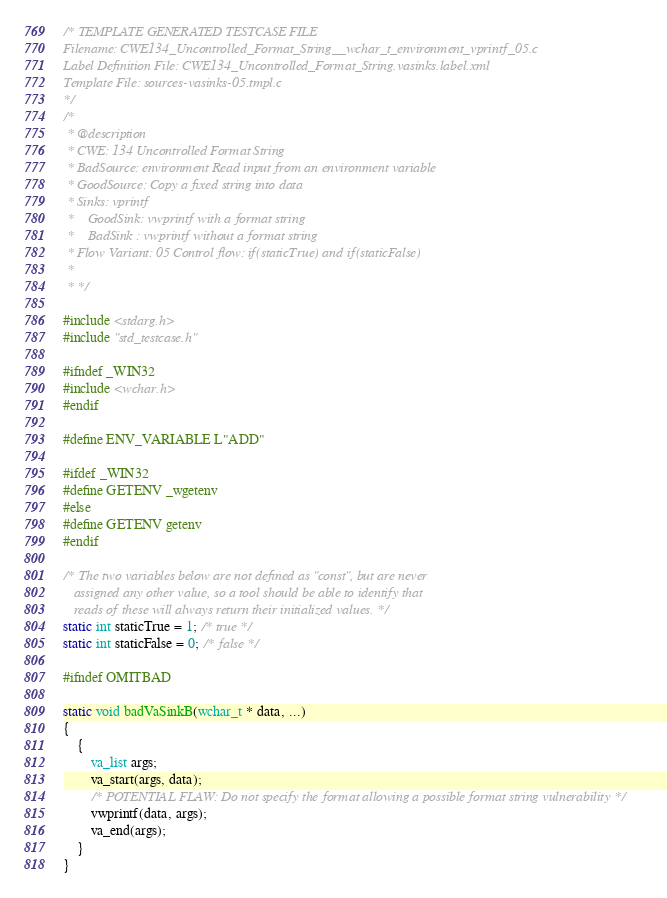<code> <loc_0><loc_0><loc_500><loc_500><_C_>/* TEMPLATE GENERATED TESTCASE FILE
Filename: CWE134_Uncontrolled_Format_String__wchar_t_environment_vprintf_05.c
Label Definition File: CWE134_Uncontrolled_Format_String.vasinks.label.xml
Template File: sources-vasinks-05.tmpl.c
*/
/*
 * @description
 * CWE: 134 Uncontrolled Format String
 * BadSource: environment Read input from an environment variable
 * GoodSource: Copy a fixed string into data
 * Sinks: vprintf
 *    GoodSink: vwprintf with a format string
 *    BadSink : vwprintf without a format string
 * Flow Variant: 05 Control flow: if(staticTrue) and if(staticFalse)
 *
 * */

#include <stdarg.h>
#include "std_testcase.h"

#ifndef _WIN32
#include <wchar.h>
#endif

#define ENV_VARIABLE L"ADD"

#ifdef _WIN32
#define GETENV _wgetenv
#else
#define GETENV getenv
#endif

/* The two variables below are not defined as "const", but are never
   assigned any other value, so a tool should be able to identify that
   reads of these will always return their initialized values. */
static int staticTrue = 1; /* true */
static int staticFalse = 0; /* false */

#ifndef OMITBAD

static void badVaSinkB(wchar_t * data, ...)
{
    {
        va_list args;
        va_start(args, data);
        /* POTENTIAL FLAW: Do not specify the format allowing a possible format string vulnerability */
        vwprintf(data, args);
        va_end(args);
    }
}
</code> 